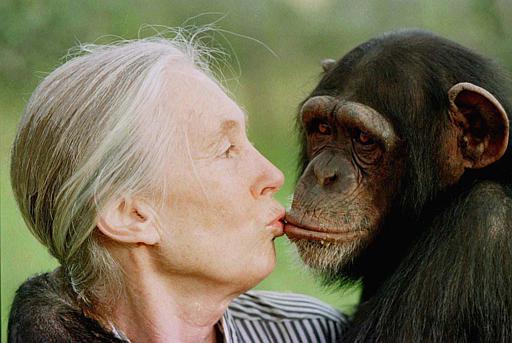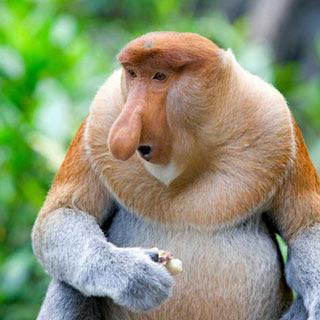The first image is the image on the left, the second image is the image on the right. For the images shown, is this caption "An elderly woman is touching the ape's face with her face." true? Answer yes or no. Yes. The first image is the image on the left, the second image is the image on the right. Examine the images to the left and right. Is the description "An older woman is showing some affection to a monkey." accurate? Answer yes or no. Yes. 